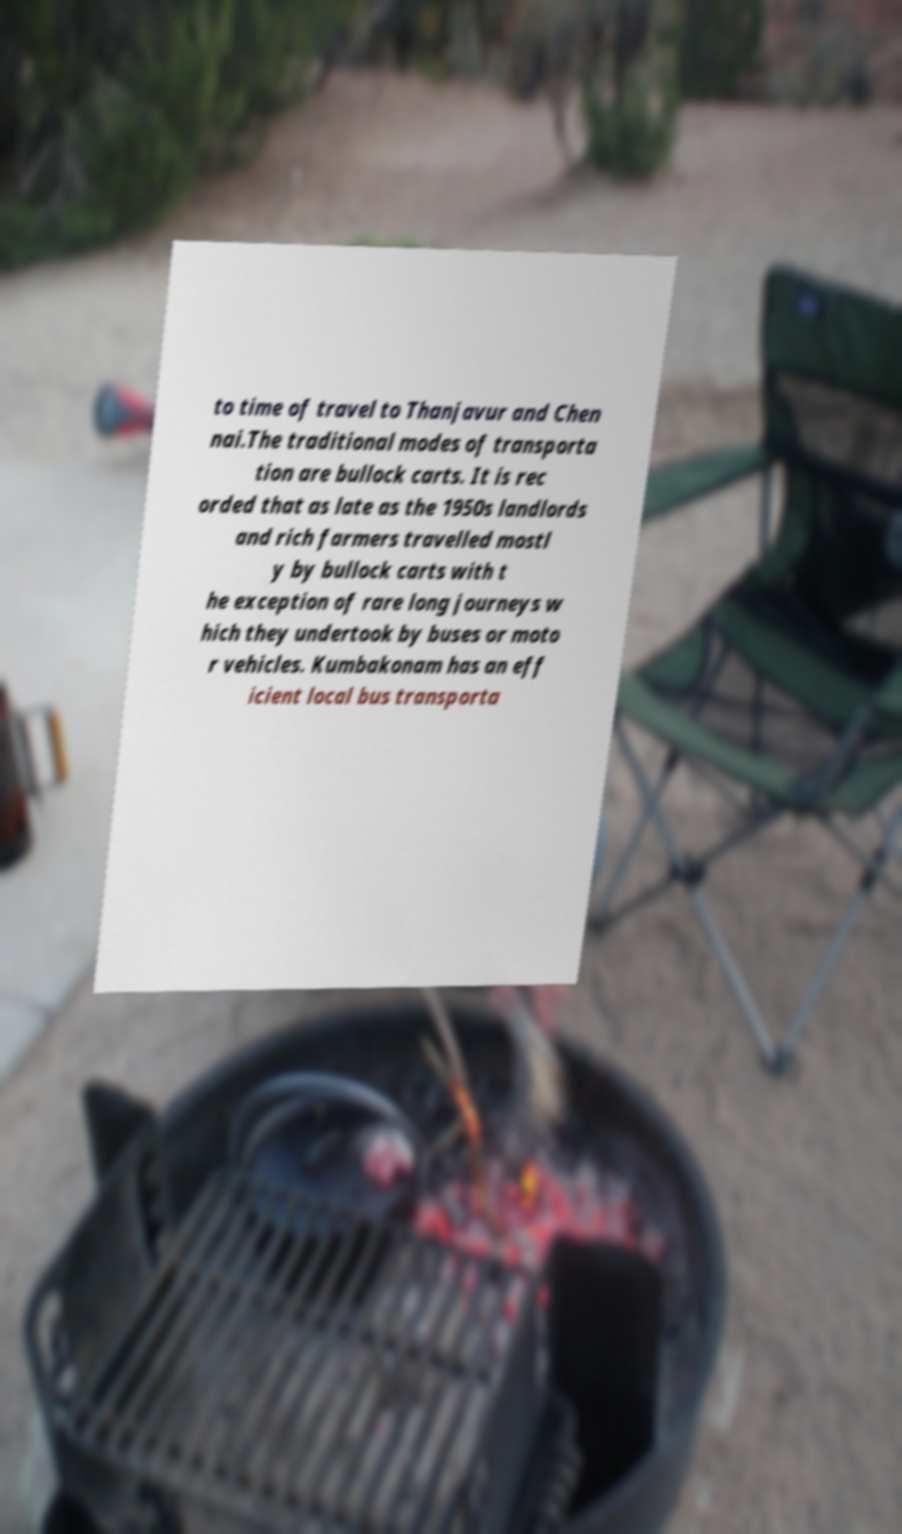For documentation purposes, I need the text within this image transcribed. Could you provide that? to time of travel to Thanjavur and Chen nai.The traditional modes of transporta tion are bullock carts. It is rec orded that as late as the 1950s landlords and rich farmers travelled mostl y by bullock carts with t he exception of rare long journeys w hich they undertook by buses or moto r vehicles. Kumbakonam has an eff icient local bus transporta 